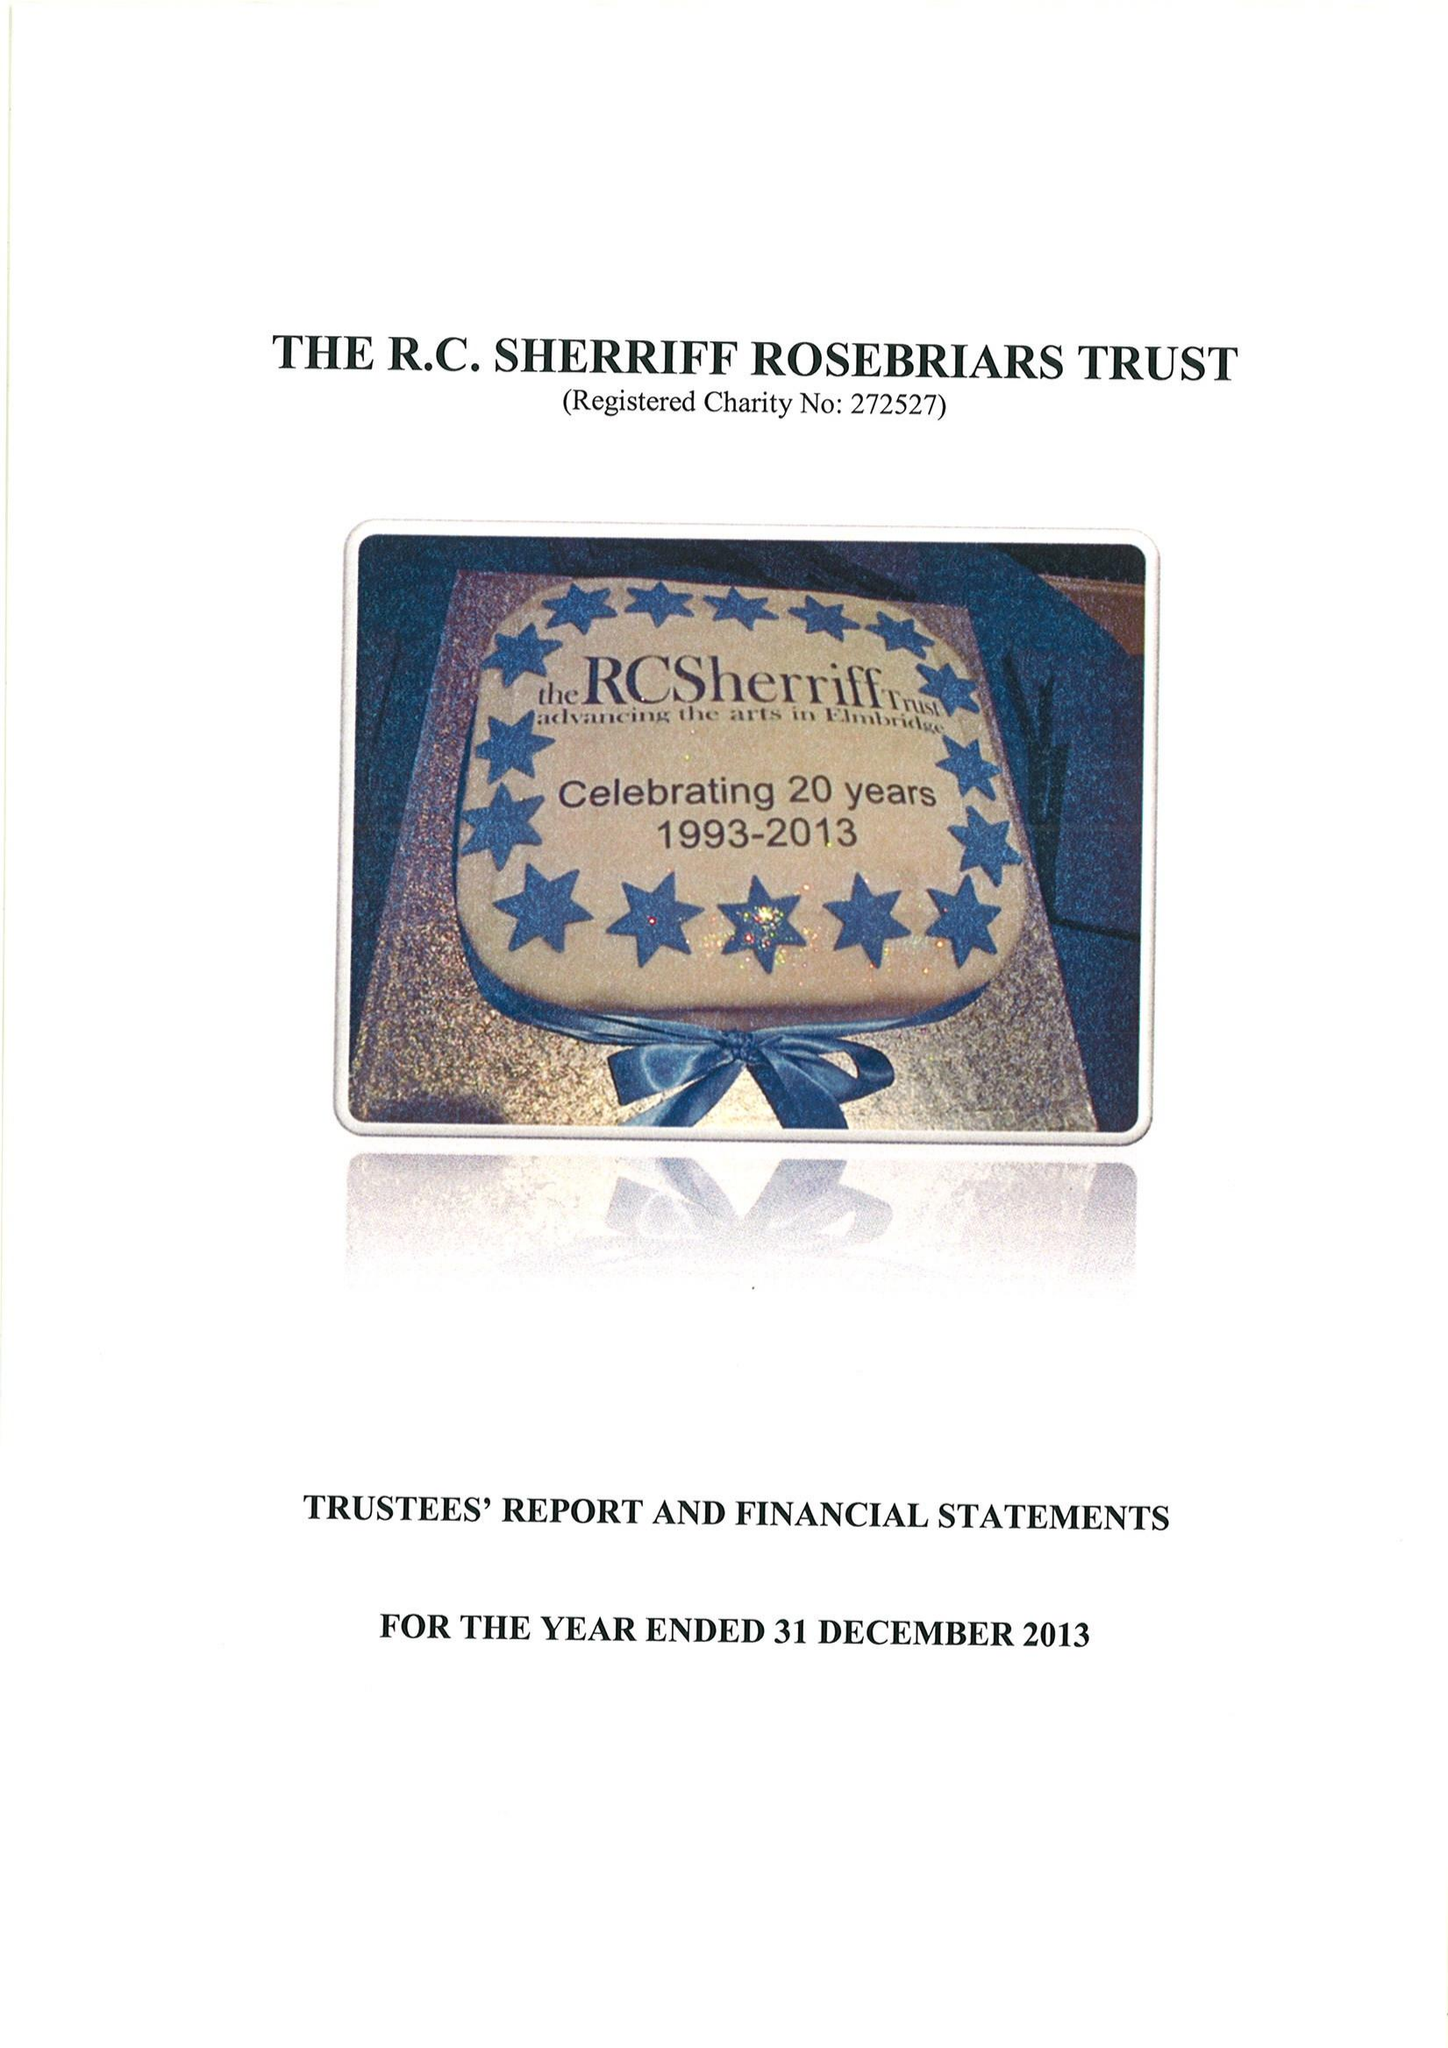What is the value for the address__post_town?
Answer the question using a single word or phrase. ESHER 